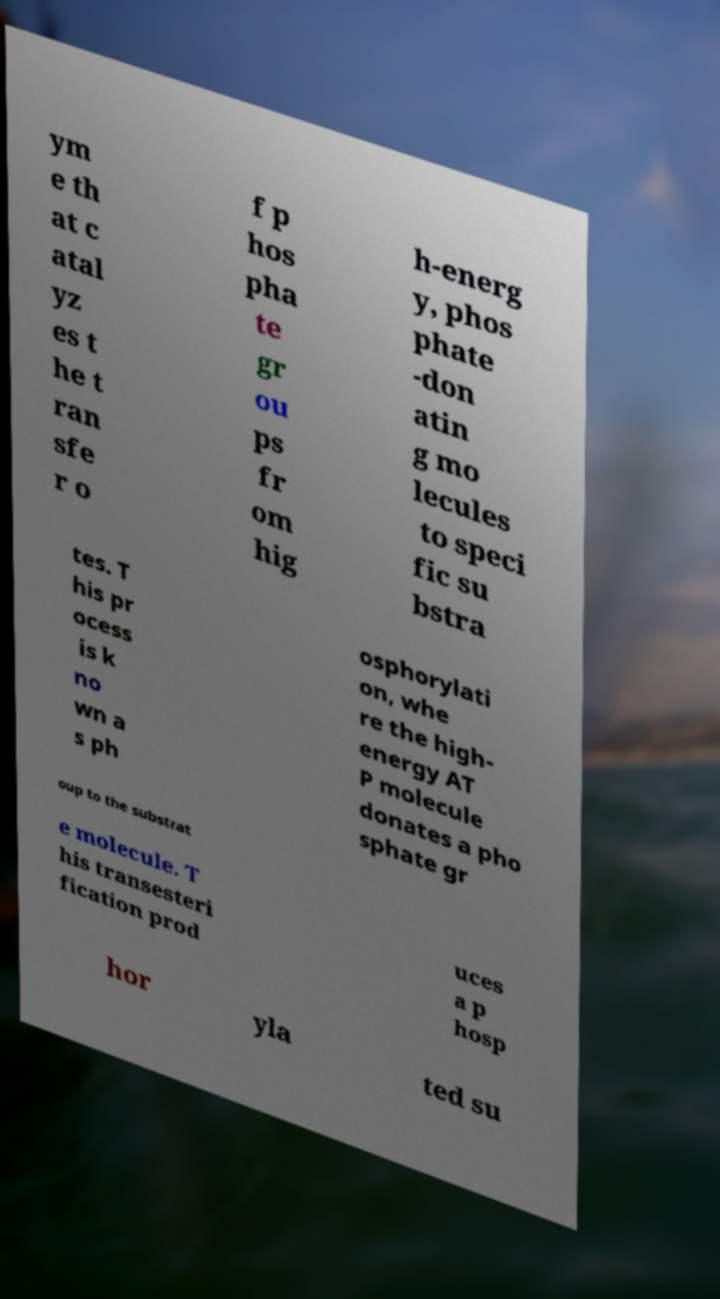Can you read and provide the text displayed in the image?This photo seems to have some interesting text. Can you extract and type it out for me? ym e th at c atal yz es t he t ran sfe r o f p hos pha te gr ou ps fr om hig h-energ y, phos phate -don atin g mo lecules to speci fic su bstra tes. T his pr ocess is k no wn a s ph osphorylati on, whe re the high- energy AT P molecule donates a pho sphate gr oup to the substrat e molecule. T his transesteri fication prod uces a p hosp hor yla ted su 